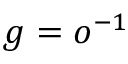Convert formula to latex. <formula><loc_0><loc_0><loc_500><loc_500>g = o ^ { - 1 }</formula> 